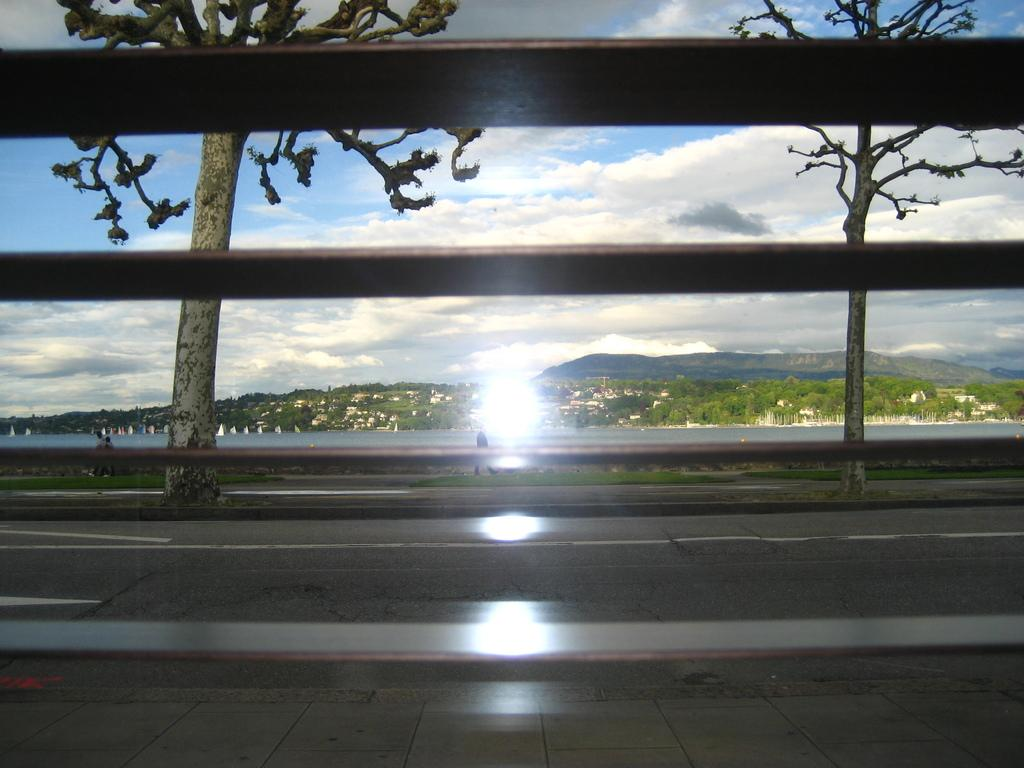What is located in the front of the image? There is fencing in the front of the image. What can be seen in the background of the image? There is a road, trees, clouds, and the sky visible in the background of the image. Can you describe the sky in the image? The sky is visible in the background of the image, and there are clouds present. What is a prominent feature in the center of the image? Sun rays are present in the center of the image. What type of patch is being sewn onto the cake in the image? There is no cake or patch present in the image. What kind of operation is being performed on the trees in the background? There is no operation being performed on the trees in the background; they are simply visible in the image. 